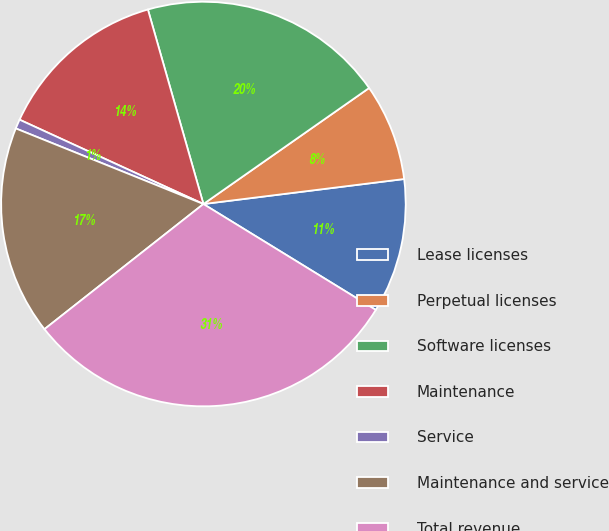Convert chart to OTSL. <chart><loc_0><loc_0><loc_500><loc_500><pie_chart><fcel>Lease licenses<fcel>Perpetual licenses<fcel>Software licenses<fcel>Maintenance<fcel>Service<fcel>Maintenance and service<fcel>Total revenue<nl><fcel>10.74%<fcel>7.75%<fcel>19.7%<fcel>13.73%<fcel>0.75%<fcel>16.71%<fcel>30.62%<nl></chart> 